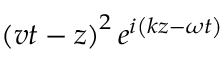<formula> <loc_0><loc_0><loc_500><loc_500>\left ( v t - z \right ) ^ { 2 } e ^ { i \left ( k z - \omega t \right ) }</formula> 